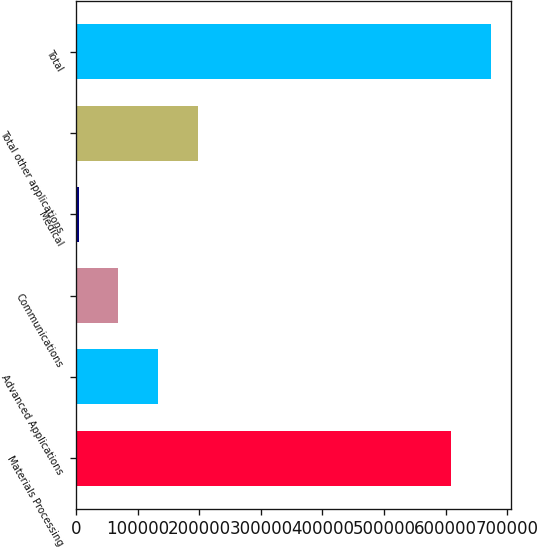Convert chart. <chart><loc_0><loc_0><loc_500><loc_500><bar_chart><fcel>Materials Processing<fcel>Advanced Applications<fcel>Communications<fcel>Medical<fcel>Total other applications<fcel>Total<nl><fcel>608702<fcel>132812<fcel>68409.7<fcel>4007<fcel>197215<fcel>673105<nl></chart> 